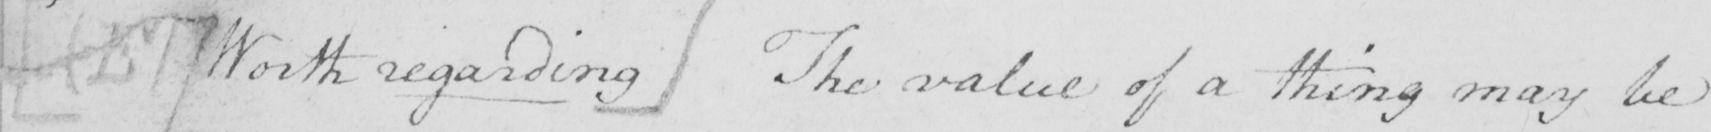Please transcribe the handwritten text in this image. [  ( E )  Worth regarding ]  The value of a thing may be 